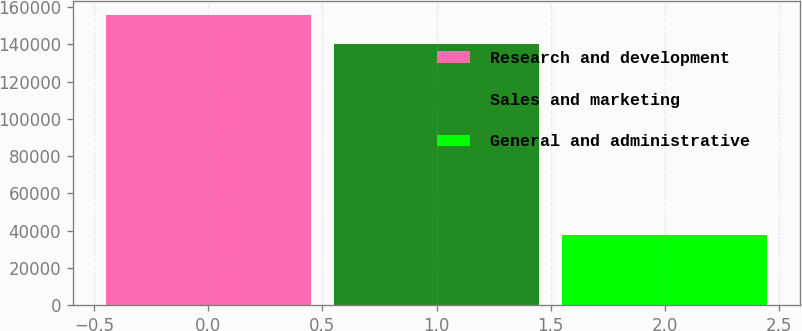Convert chart. <chart><loc_0><loc_0><loc_500><loc_500><bar_chart><fcel>Research and development<fcel>Sales and marketing<fcel>General and administrative<nl><fcel>155530<fcel>140407<fcel>37554<nl></chart> 